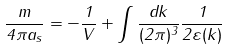Convert formula to latex. <formula><loc_0><loc_0><loc_500><loc_500>\frac { m } { 4 \pi a _ { s } } = - \frac { 1 } { V } + \int \frac { d { k } } { ( 2 \pi ) ^ { 3 } } \frac { 1 } { 2 \varepsilon ( k ) }</formula> 